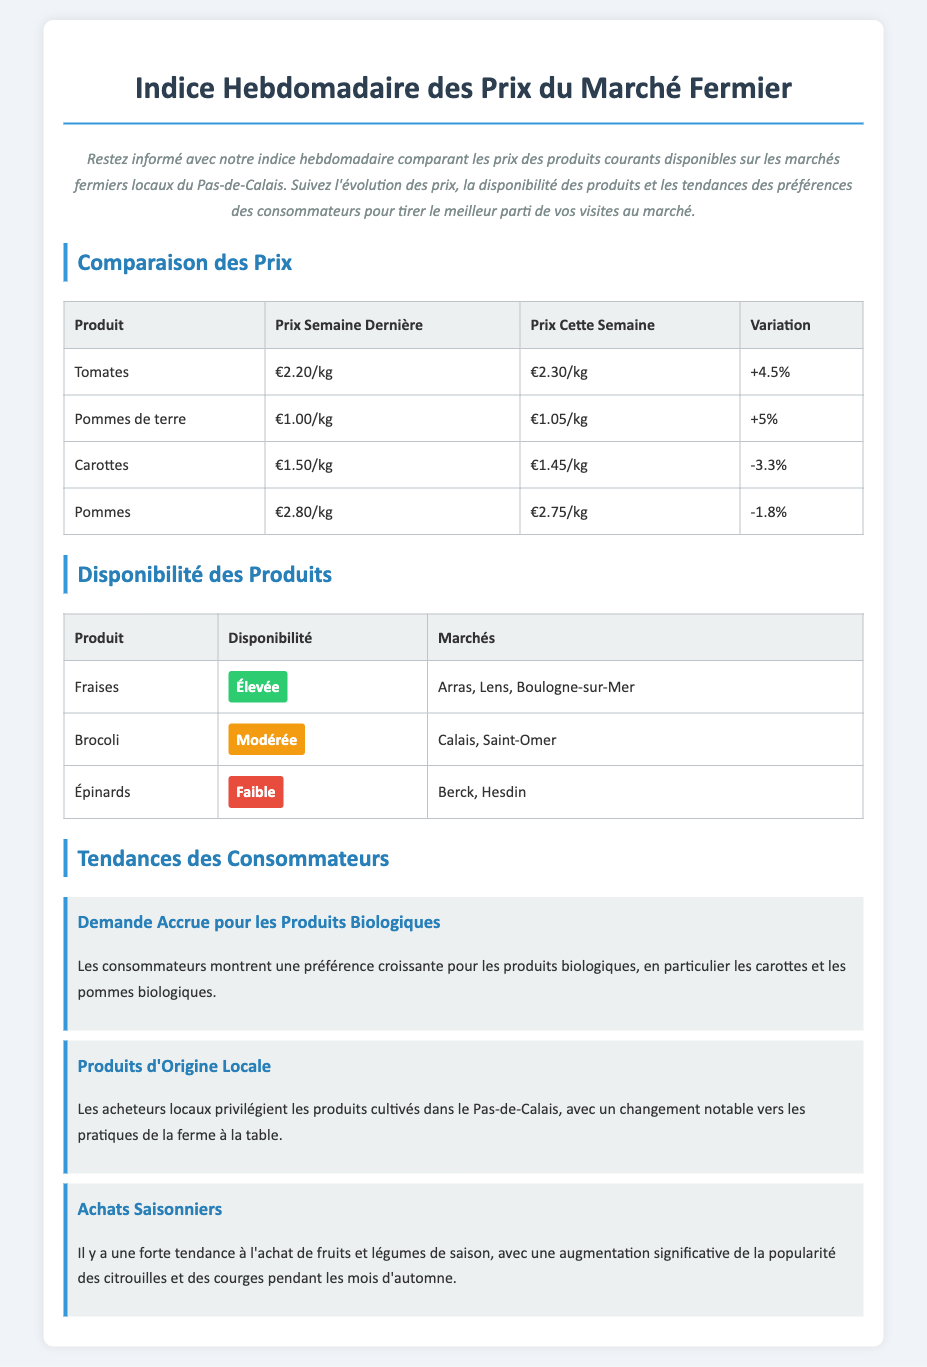what is the price of tomatoes this week? The price of tomatoes this week is listed in the comparison table under "Prix Cette Semaine," which states €2.30/kg.
Answer: €2.30/kg which product had a price decrease this week? The products that had a price decrease this week can be found in the comparison table, with "Carottes" showing a decrease of -3.3%.
Answer: Carottes how many markets sell strawberries? The availability table lists strawberries as being available in three markets, specifically "Arras, Lens, Boulogne-sur-Mer."
Answer: trois what percentage did potatoes increase in price? The increase in price for potatoes is noted in the comparison table as +5%.
Answer: +5% what is the availability status of spinach? Spinach's availability is indicated in the availability table, where it is listed as having a "Faible" status.
Answer: Faible which trend shows increasing consumer demand? The trends in the document mention a growing preference for organic products specifically highlights the increasing demand for them.
Answer: Produits Biologiques how many total trends are mentioned in the document? The document discusses three distinct trends related to consumer preferences, which include various themes.
Answer: trois which product has the highest availability status? The product with the highest availability status in the availability table is "Fraises," which is marked as Élevée.
Answer: Fraises 